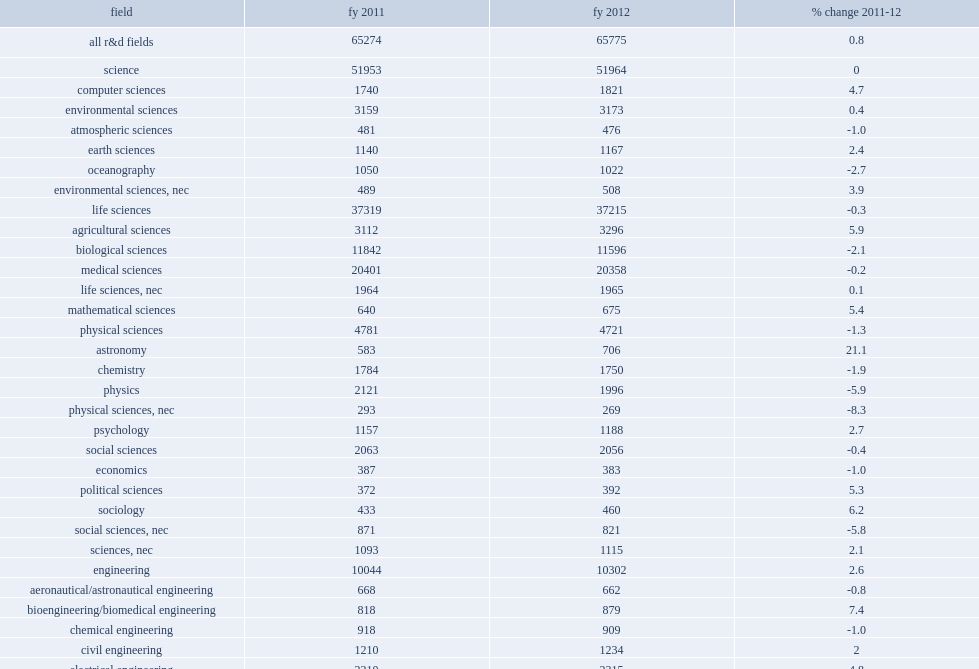The largest broad field, life sciences, how many million dollars did it decline from in fy 2011? 37319.0. The largest broad field, life sciences, how many million dollars did it decline to in fy 2011? 37215.0. How many million dollars was the majority of the funding spent within the subfields of medical sciences? 20401.0. How many million dollars did the majority of the funding spend within the subfields of biological sciences? 11596.0. 